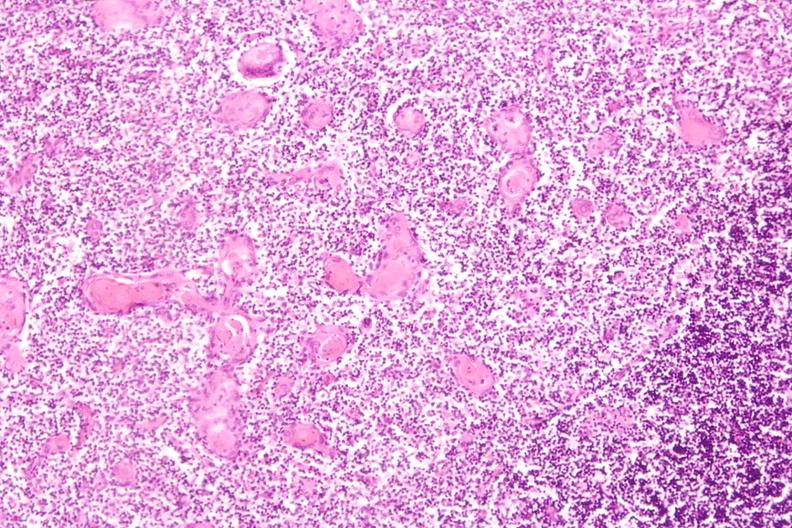what do thymus , stress induce?
Answer the question using a single word or phrase. Involution in baby with hyaline membrane disease 